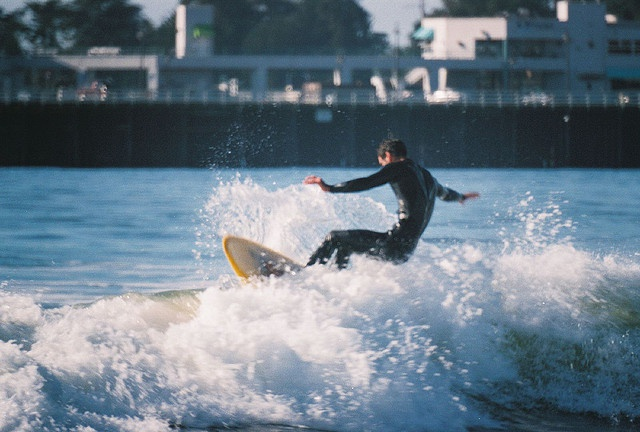Describe the objects in this image and their specific colors. I can see people in darkgray, black, gray, and blue tones and surfboard in darkgray and gray tones in this image. 